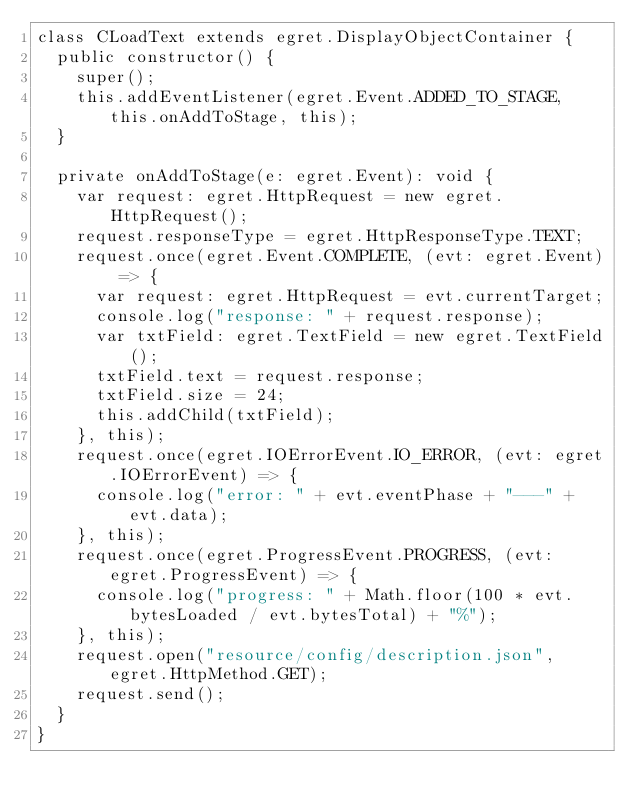<code> <loc_0><loc_0><loc_500><loc_500><_TypeScript_>class CLoadText extends egret.DisplayObjectContainer {
	public constructor() {
		super();
		this.addEventListener(egret.Event.ADDED_TO_STAGE, this.onAddToStage, this);
	}

	private onAddToStage(e: egret.Event): void {
		var request: egret.HttpRequest = new egret.HttpRequest();
		request.responseType = egret.HttpResponseType.TEXT;
		request.once(egret.Event.COMPLETE, (evt: egret.Event) => {
			var request: egret.HttpRequest = evt.currentTarget;
			console.log("response: " + request.response);
			var txtField: egret.TextField = new egret.TextField();
			txtField.text = request.response;
			txtField.size = 24;
			this.addChild(txtField);
		}, this);
		request.once(egret.IOErrorEvent.IO_ERROR, (evt: egret.IOErrorEvent) => {
			console.log("error: " + evt.eventPhase + "---" + evt.data);
		}, this);
		request.once(egret.ProgressEvent.PROGRESS, (evt: egret.ProgressEvent) => {
			console.log("progress: " + Math.floor(100 * evt.bytesLoaded / evt.bytesTotal) + "%");
		}, this);
		request.open("resource/config/description.json", egret.HttpMethod.GET);
		request.send();
	}
}</code> 